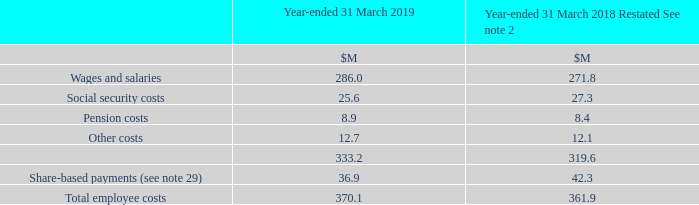11 Employee Costs
Included in wages and salaries above are $4.2M (2018: $4.0M) relating to retention payments arising on business combinations.
What was included in wages and salaries? $4.2m (2018: $4.0m) relating to retention payments arising on business combinations. What was the total employee costs in 2019?
Answer scale should be: million. 370.1. What are the types of costs considered when calculating the total employee costs? Wages and salaries, social security costs, pension costs, other costs, share-based payments. In which year was Total employee costs larger? 370.1>361.9
Answer: 2019. What was the change in total employee costs in 2019 from 2018?
Answer scale should be: million. 370.1-361.9
Answer: 8.2. What was the percentage change in total employee costs in 2019 from 2018?
Answer scale should be: percent. (370.1-361.9)/361.9
Answer: 2.27. 